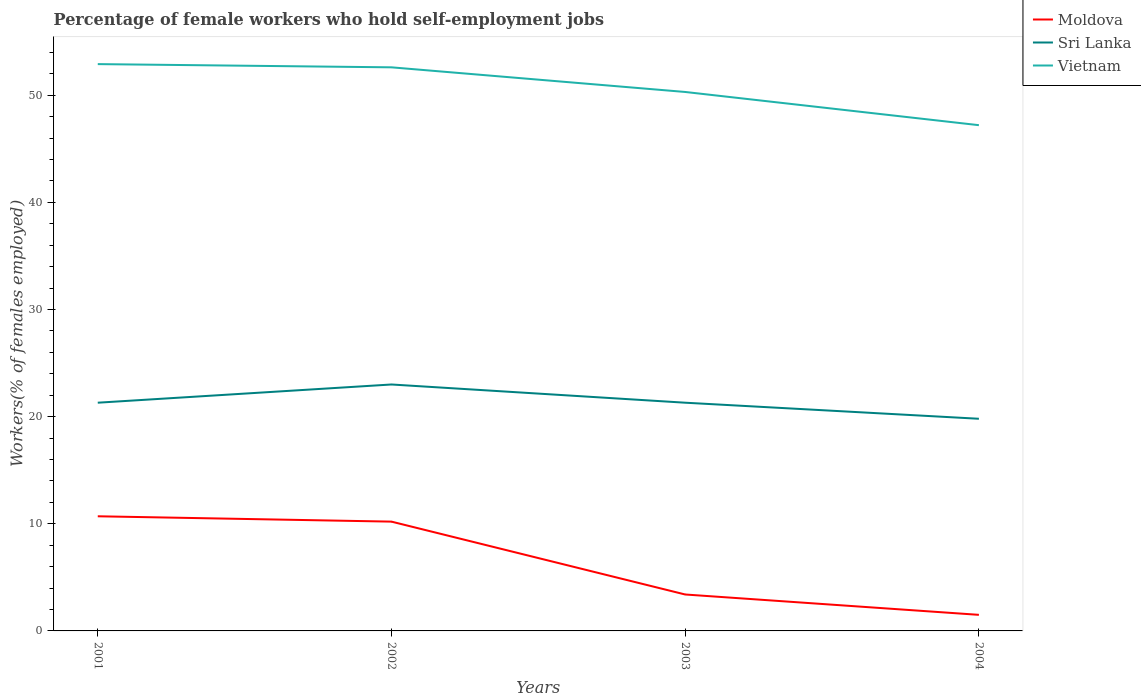Is the number of lines equal to the number of legend labels?
Provide a short and direct response. Yes. Across all years, what is the maximum percentage of self-employed female workers in Vietnam?
Your answer should be compact. 47.2. In which year was the percentage of self-employed female workers in Sri Lanka maximum?
Your answer should be compact. 2004. What is the total percentage of self-employed female workers in Moldova in the graph?
Provide a succinct answer. 0.5. What is the difference between the highest and the second highest percentage of self-employed female workers in Sri Lanka?
Offer a very short reply. 3.2. What is the difference between the highest and the lowest percentage of self-employed female workers in Moldova?
Make the answer very short. 2. Is the percentage of self-employed female workers in Sri Lanka strictly greater than the percentage of self-employed female workers in Vietnam over the years?
Provide a succinct answer. Yes. How many lines are there?
Your answer should be very brief. 3. How many years are there in the graph?
Your answer should be very brief. 4. What is the difference between two consecutive major ticks on the Y-axis?
Provide a succinct answer. 10. Does the graph contain grids?
Make the answer very short. No. How many legend labels are there?
Offer a very short reply. 3. How are the legend labels stacked?
Keep it short and to the point. Vertical. What is the title of the graph?
Ensure brevity in your answer.  Percentage of female workers who hold self-employment jobs. Does "Arab World" appear as one of the legend labels in the graph?
Provide a succinct answer. No. What is the label or title of the Y-axis?
Keep it short and to the point. Workers(% of females employed). What is the Workers(% of females employed) of Moldova in 2001?
Your answer should be compact. 10.7. What is the Workers(% of females employed) in Sri Lanka in 2001?
Provide a short and direct response. 21.3. What is the Workers(% of females employed) of Vietnam in 2001?
Ensure brevity in your answer.  52.9. What is the Workers(% of females employed) in Moldova in 2002?
Your answer should be very brief. 10.2. What is the Workers(% of females employed) of Sri Lanka in 2002?
Offer a terse response. 23. What is the Workers(% of females employed) of Vietnam in 2002?
Ensure brevity in your answer.  52.6. What is the Workers(% of females employed) in Moldova in 2003?
Provide a short and direct response. 3.4. What is the Workers(% of females employed) of Sri Lanka in 2003?
Offer a terse response. 21.3. What is the Workers(% of females employed) of Vietnam in 2003?
Your response must be concise. 50.3. What is the Workers(% of females employed) of Sri Lanka in 2004?
Give a very brief answer. 19.8. What is the Workers(% of females employed) of Vietnam in 2004?
Your response must be concise. 47.2. Across all years, what is the maximum Workers(% of females employed) of Moldova?
Your response must be concise. 10.7. Across all years, what is the maximum Workers(% of females employed) in Sri Lanka?
Your answer should be very brief. 23. Across all years, what is the maximum Workers(% of females employed) in Vietnam?
Ensure brevity in your answer.  52.9. Across all years, what is the minimum Workers(% of females employed) in Sri Lanka?
Your response must be concise. 19.8. Across all years, what is the minimum Workers(% of females employed) of Vietnam?
Your response must be concise. 47.2. What is the total Workers(% of females employed) of Moldova in the graph?
Provide a short and direct response. 25.8. What is the total Workers(% of females employed) of Sri Lanka in the graph?
Give a very brief answer. 85.4. What is the total Workers(% of females employed) of Vietnam in the graph?
Make the answer very short. 203. What is the difference between the Workers(% of females employed) of Moldova in 2001 and that in 2002?
Offer a very short reply. 0.5. What is the difference between the Workers(% of females employed) of Vietnam in 2001 and that in 2002?
Your response must be concise. 0.3. What is the difference between the Workers(% of females employed) in Sri Lanka in 2001 and that in 2003?
Ensure brevity in your answer.  0. What is the difference between the Workers(% of females employed) in Vietnam in 2001 and that in 2003?
Give a very brief answer. 2.6. What is the difference between the Workers(% of females employed) in Moldova in 2001 and that in 2004?
Give a very brief answer. 9.2. What is the difference between the Workers(% of females employed) of Sri Lanka in 2001 and that in 2004?
Ensure brevity in your answer.  1.5. What is the difference between the Workers(% of females employed) in Vietnam in 2002 and that in 2003?
Provide a succinct answer. 2.3. What is the difference between the Workers(% of females employed) of Moldova in 2002 and that in 2004?
Offer a terse response. 8.7. What is the difference between the Workers(% of females employed) in Sri Lanka in 2002 and that in 2004?
Provide a succinct answer. 3.2. What is the difference between the Workers(% of females employed) in Sri Lanka in 2003 and that in 2004?
Offer a very short reply. 1.5. What is the difference between the Workers(% of females employed) in Moldova in 2001 and the Workers(% of females employed) in Sri Lanka in 2002?
Ensure brevity in your answer.  -12.3. What is the difference between the Workers(% of females employed) in Moldova in 2001 and the Workers(% of females employed) in Vietnam in 2002?
Your response must be concise. -41.9. What is the difference between the Workers(% of females employed) of Sri Lanka in 2001 and the Workers(% of females employed) of Vietnam in 2002?
Your response must be concise. -31.3. What is the difference between the Workers(% of females employed) of Moldova in 2001 and the Workers(% of females employed) of Vietnam in 2003?
Provide a succinct answer. -39.6. What is the difference between the Workers(% of females employed) of Moldova in 2001 and the Workers(% of females employed) of Sri Lanka in 2004?
Your answer should be very brief. -9.1. What is the difference between the Workers(% of females employed) in Moldova in 2001 and the Workers(% of females employed) in Vietnam in 2004?
Your answer should be very brief. -36.5. What is the difference between the Workers(% of females employed) in Sri Lanka in 2001 and the Workers(% of females employed) in Vietnam in 2004?
Your answer should be compact. -25.9. What is the difference between the Workers(% of females employed) of Moldova in 2002 and the Workers(% of females employed) of Vietnam in 2003?
Provide a succinct answer. -40.1. What is the difference between the Workers(% of females employed) of Sri Lanka in 2002 and the Workers(% of females employed) of Vietnam in 2003?
Offer a very short reply. -27.3. What is the difference between the Workers(% of females employed) in Moldova in 2002 and the Workers(% of females employed) in Vietnam in 2004?
Provide a short and direct response. -37. What is the difference between the Workers(% of females employed) in Sri Lanka in 2002 and the Workers(% of females employed) in Vietnam in 2004?
Ensure brevity in your answer.  -24.2. What is the difference between the Workers(% of females employed) of Moldova in 2003 and the Workers(% of females employed) of Sri Lanka in 2004?
Your answer should be very brief. -16.4. What is the difference between the Workers(% of females employed) of Moldova in 2003 and the Workers(% of females employed) of Vietnam in 2004?
Your answer should be compact. -43.8. What is the difference between the Workers(% of females employed) in Sri Lanka in 2003 and the Workers(% of females employed) in Vietnam in 2004?
Keep it short and to the point. -25.9. What is the average Workers(% of females employed) of Moldova per year?
Provide a short and direct response. 6.45. What is the average Workers(% of females employed) in Sri Lanka per year?
Your response must be concise. 21.35. What is the average Workers(% of females employed) in Vietnam per year?
Offer a terse response. 50.75. In the year 2001, what is the difference between the Workers(% of females employed) in Moldova and Workers(% of females employed) in Vietnam?
Keep it short and to the point. -42.2. In the year 2001, what is the difference between the Workers(% of females employed) of Sri Lanka and Workers(% of females employed) of Vietnam?
Your response must be concise. -31.6. In the year 2002, what is the difference between the Workers(% of females employed) in Moldova and Workers(% of females employed) in Sri Lanka?
Offer a very short reply. -12.8. In the year 2002, what is the difference between the Workers(% of females employed) in Moldova and Workers(% of females employed) in Vietnam?
Offer a very short reply. -42.4. In the year 2002, what is the difference between the Workers(% of females employed) in Sri Lanka and Workers(% of females employed) in Vietnam?
Offer a very short reply. -29.6. In the year 2003, what is the difference between the Workers(% of females employed) of Moldova and Workers(% of females employed) of Sri Lanka?
Your response must be concise. -17.9. In the year 2003, what is the difference between the Workers(% of females employed) in Moldova and Workers(% of females employed) in Vietnam?
Your answer should be very brief. -46.9. In the year 2004, what is the difference between the Workers(% of females employed) of Moldova and Workers(% of females employed) of Sri Lanka?
Your answer should be compact. -18.3. In the year 2004, what is the difference between the Workers(% of females employed) in Moldova and Workers(% of females employed) in Vietnam?
Ensure brevity in your answer.  -45.7. In the year 2004, what is the difference between the Workers(% of females employed) in Sri Lanka and Workers(% of females employed) in Vietnam?
Provide a succinct answer. -27.4. What is the ratio of the Workers(% of females employed) in Moldova in 2001 to that in 2002?
Make the answer very short. 1.05. What is the ratio of the Workers(% of females employed) of Sri Lanka in 2001 to that in 2002?
Provide a short and direct response. 0.93. What is the ratio of the Workers(% of females employed) in Vietnam in 2001 to that in 2002?
Keep it short and to the point. 1.01. What is the ratio of the Workers(% of females employed) in Moldova in 2001 to that in 2003?
Your response must be concise. 3.15. What is the ratio of the Workers(% of females employed) of Vietnam in 2001 to that in 2003?
Provide a short and direct response. 1.05. What is the ratio of the Workers(% of females employed) in Moldova in 2001 to that in 2004?
Your answer should be compact. 7.13. What is the ratio of the Workers(% of females employed) of Sri Lanka in 2001 to that in 2004?
Your response must be concise. 1.08. What is the ratio of the Workers(% of females employed) of Vietnam in 2001 to that in 2004?
Your answer should be compact. 1.12. What is the ratio of the Workers(% of females employed) in Sri Lanka in 2002 to that in 2003?
Offer a very short reply. 1.08. What is the ratio of the Workers(% of females employed) of Vietnam in 2002 to that in 2003?
Keep it short and to the point. 1.05. What is the ratio of the Workers(% of females employed) of Sri Lanka in 2002 to that in 2004?
Offer a very short reply. 1.16. What is the ratio of the Workers(% of females employed) of Vietnam in 2002 to that in 2004?
Give a very brief answer. 1.11. What is the ratio of the Workers(% of females employed) of Moldova in 2003 to that in 2004?
Provide a short and direct response. 2.27. What is the ratio of the Workers(% of females employed) of Sri Lanka in 2003 to that in 2004?
Make the answer very short. 1.08. What is the ratio of the Workers(% of females employed) of Vietnam in 2003 to that in 2004?
Ensure brevity in your answer.  1.07. What is the difference between the highest and the second highest Workers(% of females employed) of Moldova?
Ensure brevity in your answer.  0.5. What is the difference between the highest and the lowest Workers(% of females employed) in Sri Lanka?
Offer a terse response. 3.2. What is the difference between the highest and the lowest Workers(% of females employed) of Vietnam?
Provide a succinct answer. 5.7. 